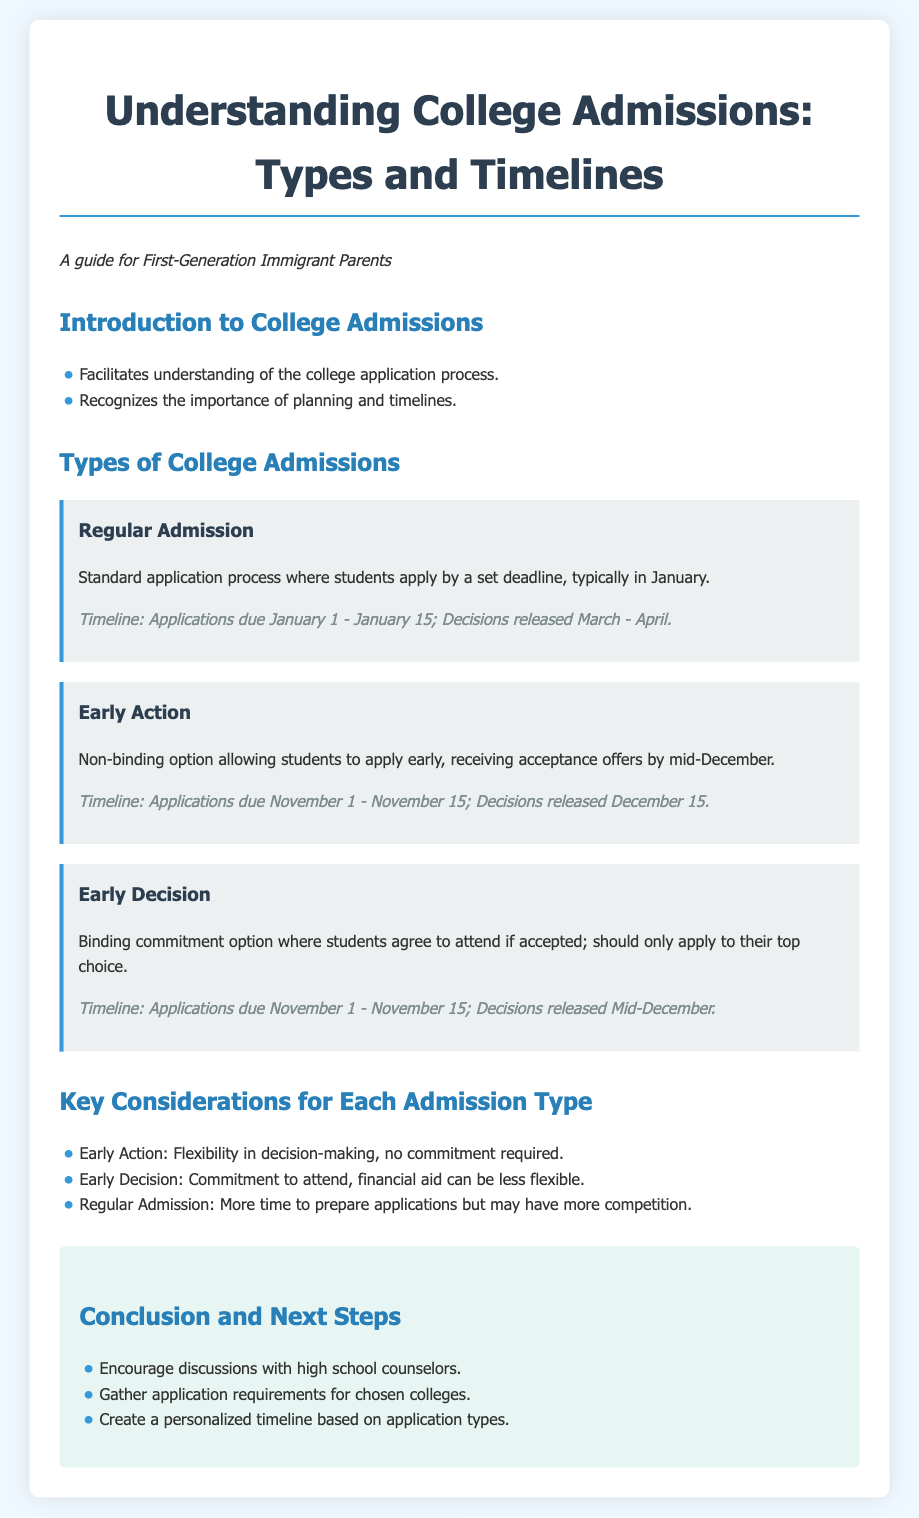What is the deadline for Regular Admission applications? The document states that Regular Admission applications are typically due between January 1 and January 15.
Answer: January 1 - January 15 When are Early Action decisions released? According to the document, decisions for Early Action are released on December 15.
Answer: December 15 What is required for Early Decision applicants? The document indicates that Early Decision requires a binding commitment to attend if accepted.
Answer: Commitment to attend How many application types are discussed in the document? The document outlines three types of college admissions: Regular Admission, Early Action, and Early Decision.
Answer: Three Which admission type provides more time to prepare applications? The document notes that Regular Admission allows for more time to prepare applications compared to the others.
Answer: Regular Admission What should students do before applying? The document encourages students to gather application requirements for chosen colleges before applying.
Answer: Gather application requirements What key consideration is mentioned for Early Action? The document states that a key consideration for Early Action is the flexibility in decision-making.
Answer: Flexibility in decision-making What is one of the next steps suggested in the conclusion? The document suggests that students should encourage discussions with high school counselors as a next step.
Answer: Discussions with high school counselors 